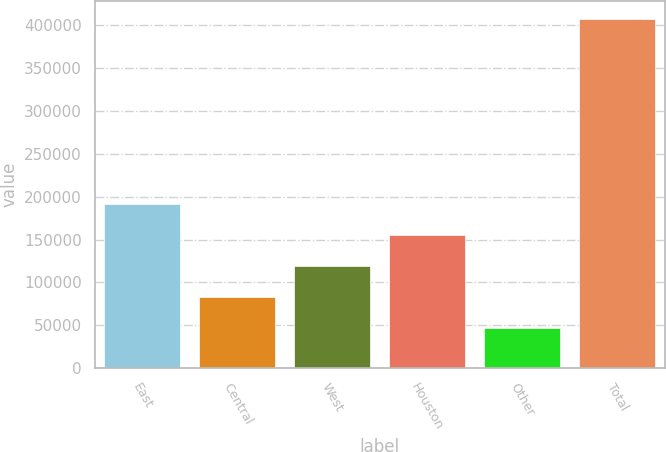<chart> <loc_0><loc_0><loc_500><loc_500><bar_chart><fcel>East<fcel>Central<fcel>West<fcel>Houston<fcel>Other<fcel>Total<nl><fcel>191345<fcel>83371.2<fcel>119362<fcel>155354<fcel>47380<fcel>407292<nl></chart> 